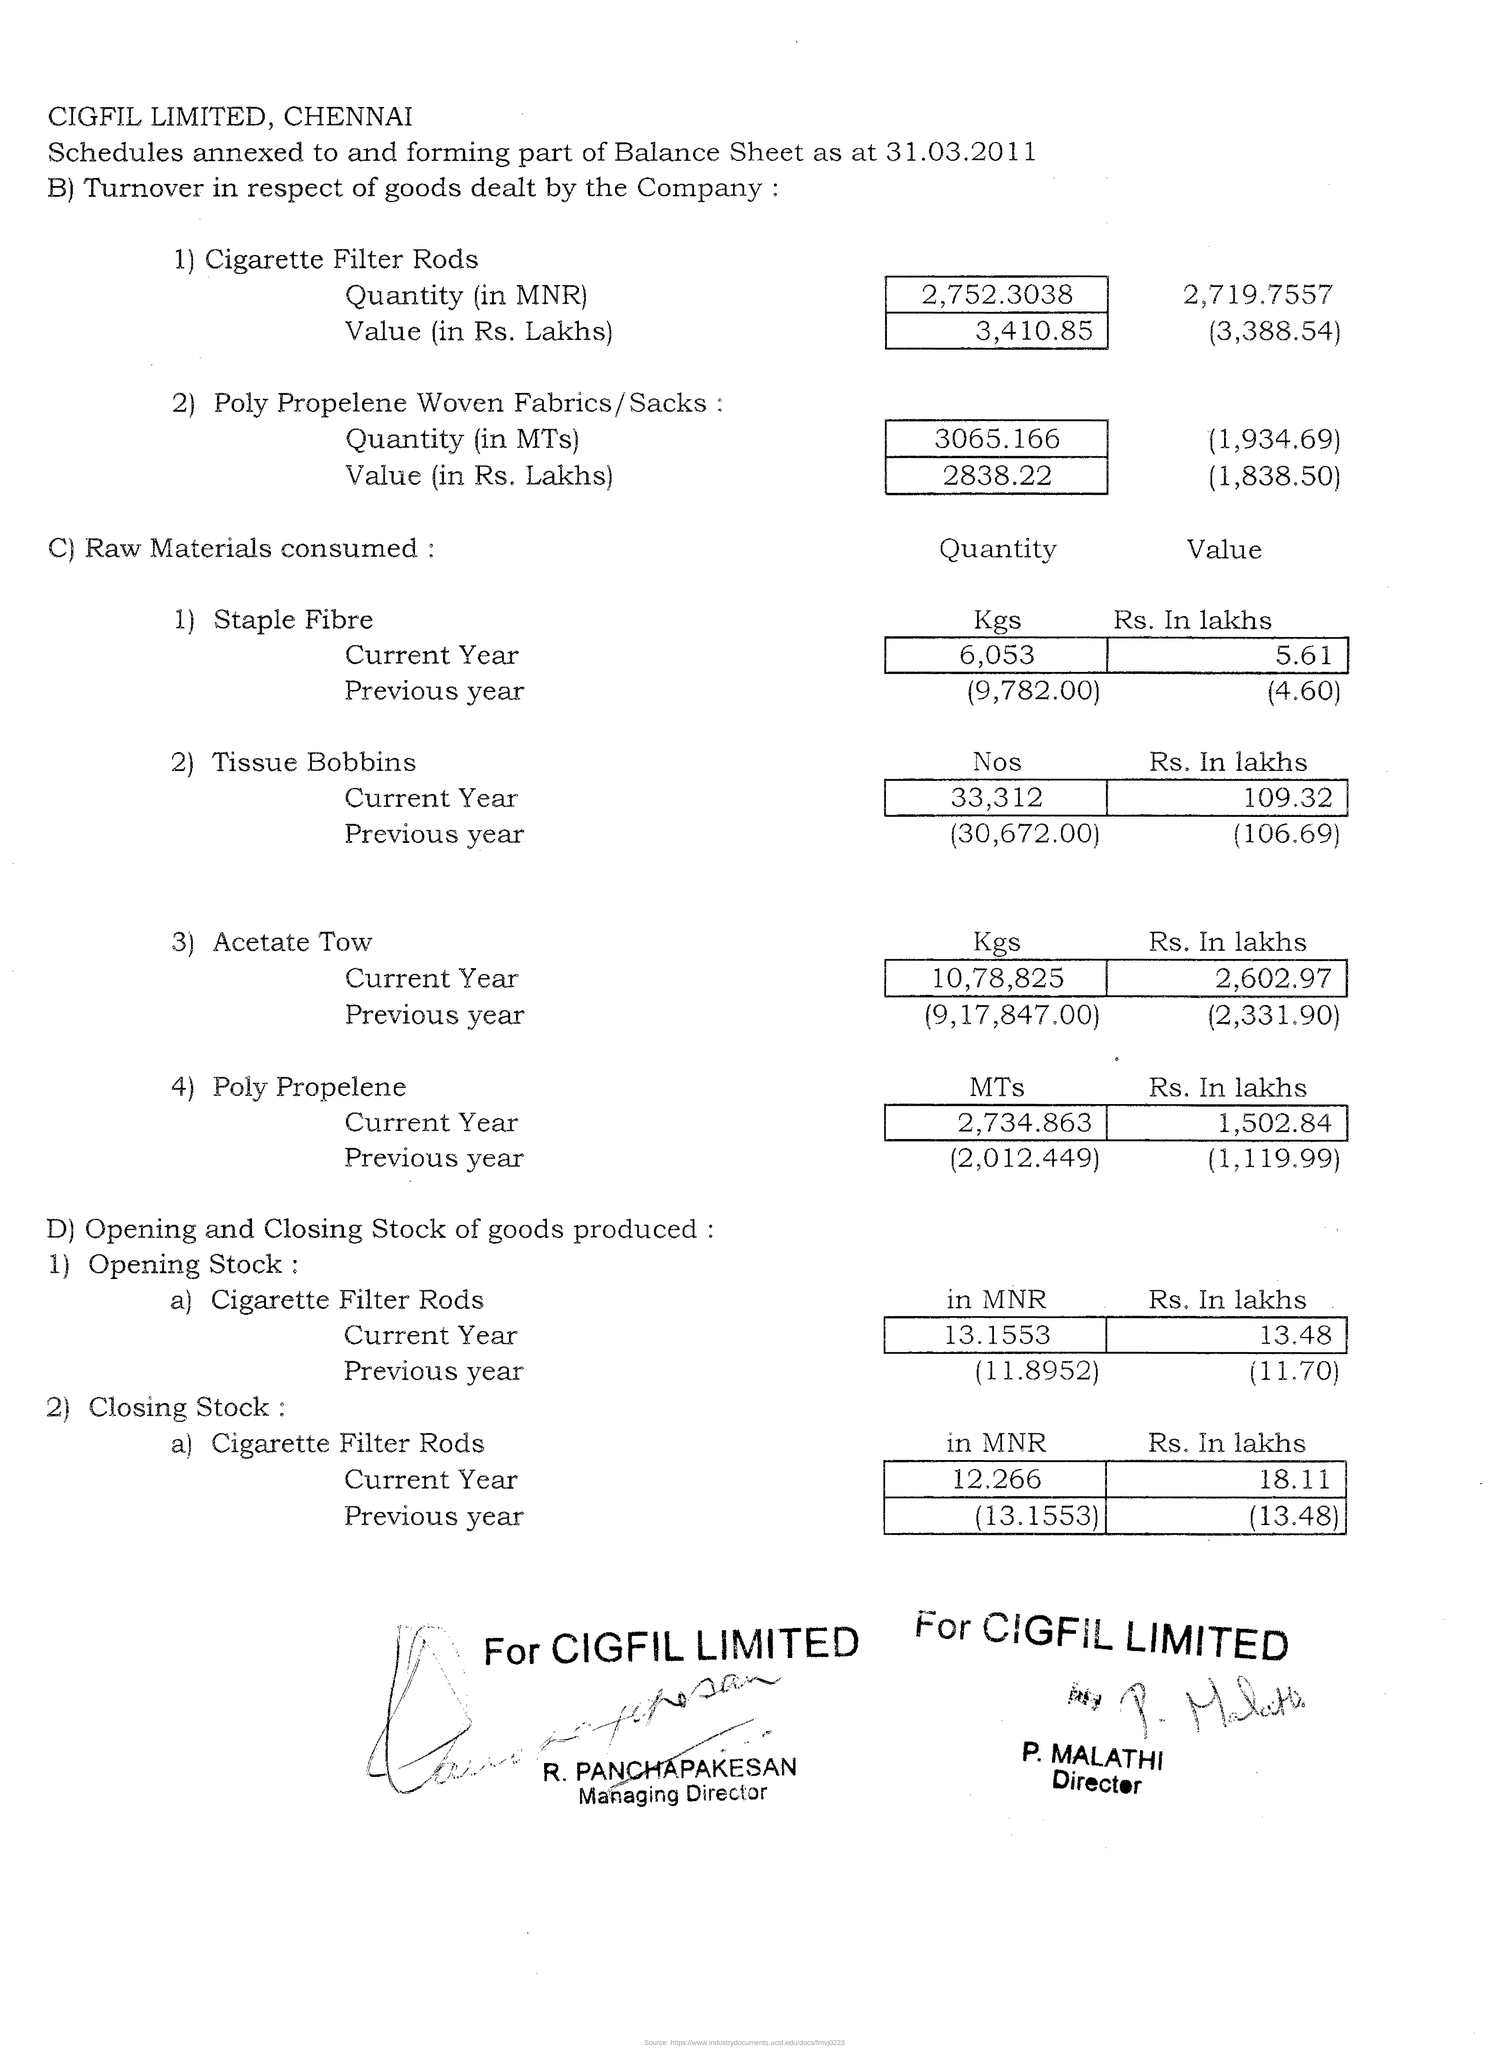Mention the company name given in capital letters?
Offer a terse response. CIGFIL LIMITED. What is the designation of "P. MALATHI"?
Your response must be concise. Director. Mention the value of "Opening stock" of Cigarette Filter Rods in Current year in MNR?
Give a very brief answer. 13.1553. What is the value of "Opening stock" of Cigarette Filter Rods in Previous year in MNR?
Your answer should be compact. (11.8952). Mention the quantity of Staple Fibre comsumed in Current year in Kgs?
Offer a very short reply. 6,053. Mention the quantity of Tissue Bobbins consumed in Current year in Nos?
Offer a terse response. 33,312. Mention the quantity of Acetate Tow consumed in Current year in Kgs?
Ensure brevity in your answer.  10,78,825. Mention the quantity of Poly Propelene consumed in Previous year in MTs?
Give a very brief answer. (2,012.449). 